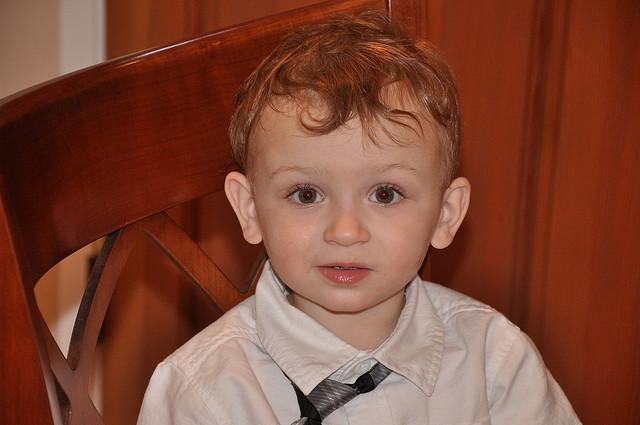Is the boy's hair the same color as the chair?
Answer briefly. Yes. Does he look scared?
Keep it brief. No. Does this person have a tattoo?
Concise answer only. No. Is this child laughing?
Give a very brief answer. No. In which decade do you think this photo was taken?
Be succinct. 2010. Is this a child?
Concise answer only. Yes. Does this person have acne?
Answer briefly. No. Who is this person?
Short answer required. Boy. Are the boys eyes open?
Short answer required. Yes. 